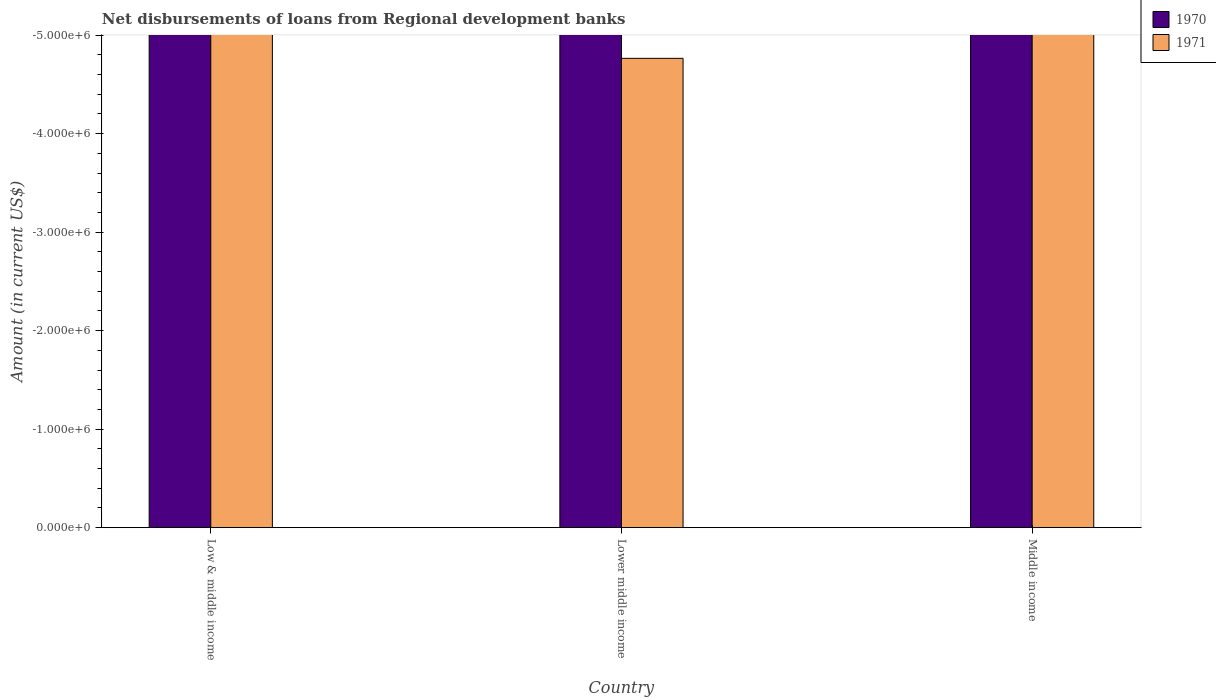How many different coloured bars are there?
Offer a very short reply. 0. Are the number of bars per tick equal to the number of legend labels?
Your answer should be very brief. No. Are the number of bars on each tick of the X-axis equal?
Offer a very short reply. Yes. How many bars are there on the 2nd tick from the left?
Give a very brief answer. 0. How many bars are there on the 1st tick from the right?
Keep it short and to the point. 0. In how many cases, is the number of bars for a given country not equal to the number of legend labels?
Offer a very short reply. 3. What is the amount of disbursements of loans from regional development banks in 1971 in Middle income?
Your answer should be very brief. 0. Across all countries, what is the minimum amount of disbursements of loans from regional development banks in 1970?
Your answer should be compact. 0. What is the total amount of disbursements of loans from regional development banks in 1971 in the graph?
Provide a short and direct response. 0. What is the average amount of disbursements of loans from regional development banks in 1970 per country?
Your response must be concise. 0. In how many countries, is the amount of disbursements of loans from regional development banks in 1971 greater than the average amount of disbursements of loans from regional development banks in 1971 taken over all countries?
Offer a terse response. 0. How many bars are there?
Your response must be concise. 0. Are all the bars in the graph horizontal?
Offer a terse response. No. How are the legend labels stacked?
Provide a succinct answer. Vertical. What is the title of the graph?
Your answer should be compact. Net disbursements of loans from Regional development banks. Does "1976" appear as one of the legend labels in the graph?
Provide a succinct answer. No. What is the label or title of the X-axis?
Your answer should be compact. Country. What is the Amount (in current US$) in 1971 in Low & middle income?
Provide a short and direct response. 0. What is the Amount (in current US$) of 1970 in Lower middle income?
Your response must be concise. 0. What is the Amount (in current US$) in 1971 in Lower middle income?
Provide a short and direct response. 0. What is the Amount (in current US$) of 1971 in Middle income?
Offer a very short reply. 0. What is the total Amount (in current US$) in 1970 in the graph?
Your answer should be compact. 0. What is the total Amount (in current US$) of 1971 in the graph?
Ensure brevity in your answer.  0. What is the average Amount (in current US$) in 1971 per country?
Offer a very short reply. 0. 